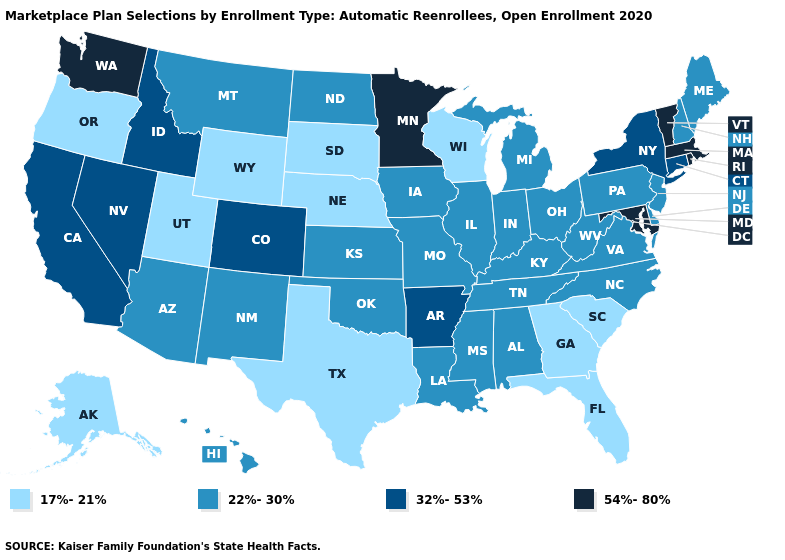What is the highest value in states that border Delaware?
Answer briefly. 54%-80%. What is the highest value in states that border Montana?
Short answer required. 32%-53%. Name the states that have a value in the range 54%-80%?
Quick response, please. Maryland, Massachusetts, Minnesota, Rhode Island, Vermont, Washington. What is the value of South Carolina?
Concise answer only. 17%-21%. Does Oregon have the lowest value in the West?
Short answer required. Yes. What is the value of Colorado?
Give a very brief answer. 32%-53%. How many symbols are there in the legend?
Concise answer only. 4. What is the highest value in the South ?
Be succinct. 54%-80%. Does the map have missing data?
Keep it brief. No. Does the map have missing data?
Give a very brief answer. No. Name the states that have a value in the range 17%-21%?
Concise answer only. Alaska, Florida, Georgia, Nebraska, Oregon, South Carolina, South Dakota, Texas, Utah, Wisconsin, Wyoming. What is the lowest value in the USA?
Short answer required. 17%-21%. Does Nebraska have the lowest value in the USA?
Concise answer only. Yes. Among the states that border Michigan , does Wisconsin have the highest value?
Be succinct. No. What is the lowest value in states that border New Mexico?
Be succinct. 17%-21%. 